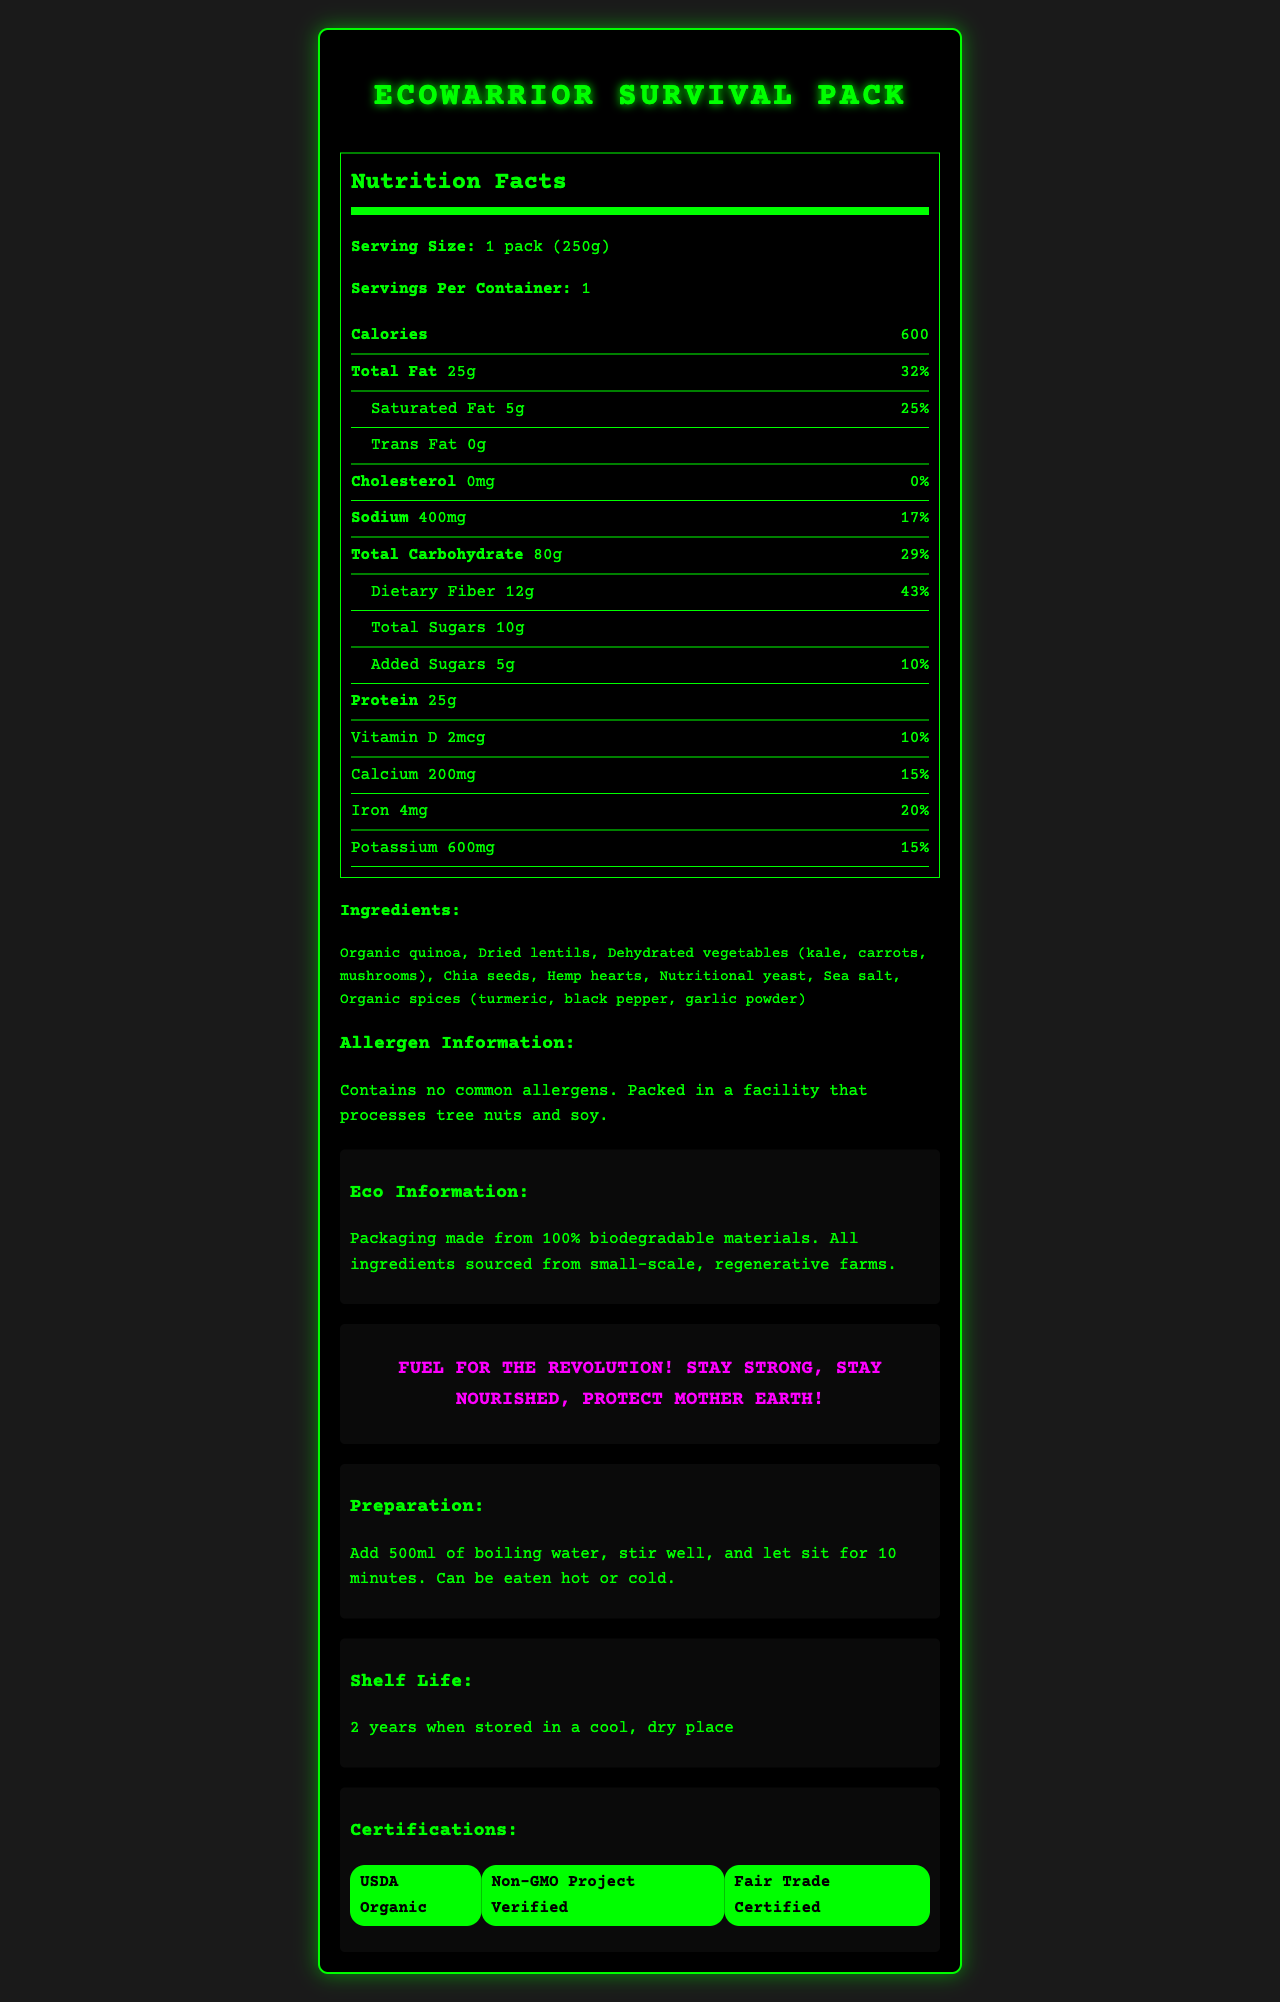what is the serving size for the EcoWarrior Survival Pack? The serving size is explicitly mentioned in the "Serving Size" section of the nutrition facts.
Answer: 1 pack (250g) how many calories are in a single serving of the EcoWarrior Survival Pack? The calorie count per serving is stated directly under the calories section in the nutrition facts.
Answer: 600 how much protein does one pack contain? The protein content per pack is listed under the nutrition facts section.
Answer: 25g what is the total carbohydrate content, including dietary fiber and sugars? The total carbohydrate content is 80g, as indicated in the nutrition facts section.
Answer: 80g what is the daily value percentage of dietary fiber in one serving? The daily value percentage for dietary fiber is listed as 43% in the nutrition facts section.
Answer: 43% which ingredient is not a part of the EcoWarrior Survival Pack's ingredient list? A. Organic quinoa B. Dried lentils C. Dehydrated vegetables D. Organic oats Organic oats are not mentioned in the ingredient list; the other options are part of the ingredient list.
Answer: D how much sodium does the EcoWarrior Survival Pack contain? The sodium content of 400mg is listed in the nutrition facts section.
Answer: 400mg what certifications does the EcoWarrior Survival Pack have? A. USDA Organic B. Non-GMO Project Verified C. Fair Trade Certified D. All of the above The document states that the product is USDA Organic, Non-GMO Project Verified, and Fair Trade Certified.
Answer: D is there any cholesterol in the EcoWarrior Survival Pack? The nutrition facts indicate that the cholesterol content is 0mg, which means it has no cholesterol.
Answer: No describe the allergen information noted for the EcoWarrior Survival Pack. The allergen information can be found in the section labeled "Allergen Information," where it states that the product contains no common allergens and is processed in a facility with tree nuts and soy.
Answer: The pack contains no common allergens. It is packed in a facility that processes tree nuts and soy. how should the EcoWarrior Survival Pack be prepared? The preparation instructions are explicitly provided in the "Preparation" section of the document.
Answer: Add 500ml of boiling water, stir well, and let sit for 10 minutes. Can be eaten hot or cold. what is the shelf life of the EcoWarrior Survival Pack? The shelf life is mentioned at the end of the document in the "Shelf Life" section.
Answer: 2 years when stored in a cool, dry place can this food pack be consumed by someone with a soy allergy? The allergen information specifies that the product is packed in a facility that processes soy, but it does not definitively say if it is free from soy contamination.
Answer: Not enough information 